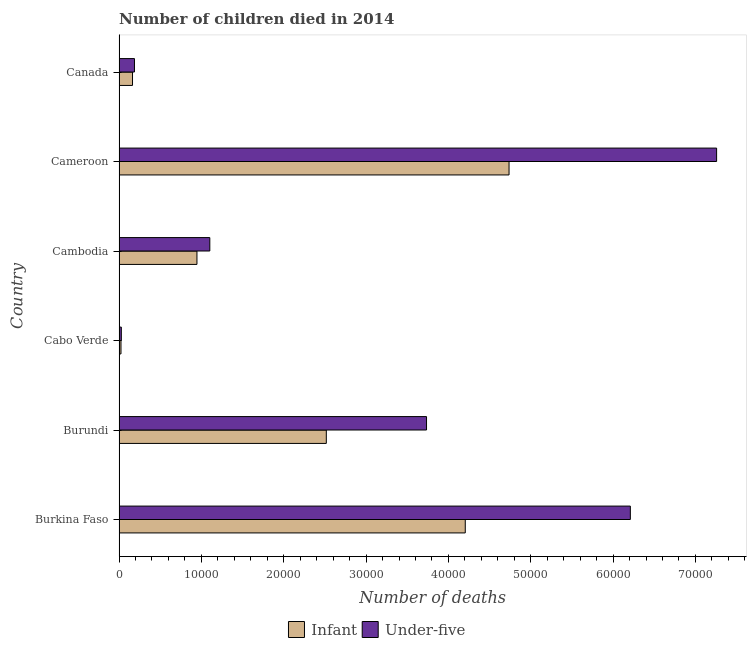How many groups of bars are there?
Make the answer very short. 6. Are the number of bars per tick equal to the number of legend labels?
Your answer should be compact. Yes. How many bars are there on the 6th tick from the top?
Give a very brief answer. 2. What is the label of the 2nd group of bars from the top?
Your answer should be compact. Cameroon. What is the number of infant deaths in Canada?
Provide a short and direct response. 1636. Across all countries, what is the maximum number of under-five deaths?
Provide a short and direct response. 7.26e+04. Across all countries, what is the minimum number of infant deaths?
Provide a short and direct response. 235. In which country was the number of infant deaths maximum?
Your answer should be very brief. Cameroon. In which country was the number of under-five deaths minimum?
Your response must be concise. Cabo Verde. What is the total number of under-five deaths in the graph?
Provide a short and direct response. 1.85e+05. What is the difference between the number of infant deaths in Cabo Verde and that in Cameroon?
Your answer should be very brief. -4.71e+04. What is the difference between the number of under-five deaths in Cameroon and the number of infant deaths in Cambodia?
Ensure brevity in your answer.  6.31e+04. What is the average number of infant deaths per country?
Your answer should be very brief. 2.10e+04. What is the difference between the number of under-five deaths and number of infant deaths in Cabo Verde?
Ensure brevity in your answer.  42. In how many countries, is the number of under-five deaths greater than 48000 ?
Your answer should be compact. 2. What is the ratio of the number of infant deaths in Cabo Verde to that in Cambodia?
Ensure brevity in your answer.  0.03. Is the number of under-five deaths in Burkina Faso less than that in Burundi?
Ensure brevity in your answer.  No. Is the difference between the number of under-five deaths in Burundi and Cambodia greater than the difference between the number of infant deaths in Burundi and Cambodia?
Keep it short and to the point. Yes. What is the difference between the highest and the second highest number of infant deaths?
Your answer should be compact. 5317. What is the difference between the highest and the lowest number of infant deaths?
Ensure brevity in your answer.  4.71e+04. In how many countries, is the number of infant deaths greater than the average number of infant deaths taken over all countries?
Offer a very short reply. 3. What does the 1st bar from the top in Cameroon represents?
Offer a very short reply. Under-five. What does the 2nd bar from the bottom in Burundi represents?
Offer a terse response. Under-five. How many bars are there?
Provide a succinct answer. 12. Are all the bars in the graph horizontal?
Keep it short and to the point. Yes. Are the values on the major ticks of X-axis written in scientific E-notation?
Make the answer very short. No. How many legend labels are there?
Keep it short and to the point. 2. How are the legend labels stacked?
Make the answer very short. Horizontal. What is the title of the graph?
Your response must be concise. Number of children died in 2014. What is the label or title of the X-axis?
Provide a short and direct response. Number of deaths. What is the label or title of the Y-axis?
Your answer should be very brief. Country. What is the Number of deaths of Infant in Burkina Faso?
Ensure brevity in your answer.  4.20e+04. What is the Number of deaths in Under-five in Burkina Faso?
Make the answer very short. 6.21e+04. What is the Number of deaths in Infant in Burundi?
Make the answer very short. 2.52e+04. What is the Number of deaths in Under-five in Burundi?
Your response must be concise. 3.73e+04. What is the Number of deaths of Infant in Cabo Verde?
Give a very brief answer. 235. What is the Number of deaths in Under-five in Cabo Verde?
Your answer should be very brief. 277. What is the Number of deaths of Infant in Cambodia?
Make the answer very short. 9461. What is the Number of deaths in Under-five in Cambodia?
Offer a terse response. 1.10e+04. What is the Number of deaths in Infant in Cameroon?
Give a very brief answer. 4.74e+04. What is the Number of deaths of Under-five in Cameroon?
Your answer should be compact. 7.26e+04. What is the Number of deaths of Infant in Canada?
Keep it short and to the point. 1636. What is the Number of deaths of Under-five in Canada?
Your answer should be very brief. 1872. Across all countries, what is the maximum Number of deaths of Infant?
Give a very brief answer. 4.74e+04. Across all countries, what is the maximum Number of deaths of Under-five?
Offer a terse response. 7.26e+04. Across all countries, what is the minimum Number of deaths in Infant?
Ensure brevity in your answer.  235. Across all countries, what is the minimum Number of deaths of Under-five?
Offer a very short reply. 277. What is the total Number of deaths of Infant in the graph?
Your answer should be compact. 1.26e+05. What is the total Number of deaths in Under-five in the graph?
Offer a very short reply. 1.85e+05. What is the difference between the Number of deaths in Infant in Burkina Faso and that in Burundi?
Provide a succinct answer. 1.69e+04. What is the difference between the Number of deaths in Under-five in Burkina Faso and that in Burundi?
Your response must be concise. 2.48e+04. What is the difference between the Number of deaths of Infant in Burkina Faso and that in Cabo Verde?
Offer a terse response. 4.18e+04. What is the difference between the Number of deaths of Under-five in Burkina Faso and that in Cabo Verde?
Give a very brief answer. 6.18e+04. What is the difference between the Number of deaths of Infant in Burkina Faso and that in Cambodia?
Ensure brevity in your answer.  3.26e+04. What is the difference between the Number of deaths of Under-five in Burkina Faso and that in Cambodia?
Offer a terse response. 5.11e+04. What is the difference between the Number of deaths of Infant in Burkina Faso and that in Cameroon?
Provide a succinct answer. -5317. What is the difference between the Number of deaths in Under-five in Burkina Faso and that in Cameroon?
Keep it short and to the point. -1.05e+04. What is the difference between the Number of deaths of Infant in Burkina Faso and that in Canada?
Provide a succinct answer. 4.04e+04. What is the difference between the Number of deaths of Under-five in Burkina Faso and that in Canada?
Your response must be concise. 6.02e+04. What is the difference between the Number of deaths of Infant in Burundi and that in Cabo Verde?
Offer a terse response. 2.49e+04. What is the difference between the Number of deaths of Under-five in Burundi and that in Cabo Verde?
Provide a short and direct response. 3.71e+04. What is the difference between the Number of deaths of Infant in Burundi and that in Cambodia?
Make the answer very short. 1.57e+04. What is the difference between the Number of deaths in Under-five in Burundi and that in Cambodia?
Provide a succinct answer. 2.63e+04. What is the difference between the Number of deaths in Infant in Burundi and that in Cameroon?
Keep it short and to the point. -2.22e+04. What is the difference between the Number of deaths in Under-five in Burundi and that in Cameroon?
Keep it short and to the point. -3.52e+04. What is the difference between the Number of deaths of Infant in Burundi and that in Canada?
Your response must be concise. 2.35e+04. What is the difference between the Number of deaths in Under-five in Burundi and that in Canada?
Your answer should be very brief. 3.55e+04. What is the difference between the Number of deaths of Infant in Cabo Verde and that in Cambodia?
Offer a very short reply. -9226. What is the difference between the Number of deaths of Under-five in Cabo Verde and that in Cambodia?
Your response must be concise. -1.07e+04. What is the difference between the Number of deaths of Infant in Cabo Verde and that in Cameroon?
Offer a terse response. -4.71e+04. What is the difference between the Number of deaths in Under-five in Cabo Verde and that in Cameroon?
Your answer should be compact. -7.23e+04. What is the difference between the Number of deaths of Infant in Cabo Verde and that in Canada?
Your answer should be very brief. -1401. What is the difference between the Number of deaths of Under-five in Cabo Verde and that in Canada?
Your response must be concise. -1595. What is the difference between the Number of deaths of Infant in Cambodia and that in Cameroon?
Provide a succinct answer. -3.79e+04. What is the difference between the Number of deaths of Under-five in Cambodia and that in Cameroon?
Your answer should be very brief. -6.16e+04. What is the difference between the Number of deaths of Infant in Cambodia and that in Canada?
Your response must be concise. 7825. What is the difference between the Number of deaths of Under-five in Cambodia and that in Canada?
Provide a short and direct response. 9150. What is the difference between the Number of deaths of Infant in Cameroon and that in Canada?
Offer a very short reply. 4.57e+04. What is the difference between the Number of deaths in Under-five in Cameroon and that in Canada?
Give a very brief answer. 7.07e+04. What is the difference between the Number of deaths of Infant in Burkina Faso and the Number of deaths of Under-five in Burundi?
Provide a succinct answer. 4705. What is the difference between the Number of deaths in Infant in Burkina Faso and the Number of deaths in Under-five in Cabo Verde?
Ensure brevity in your answer.  4.18e+04. What is the difference between the Number of deaths of Infant in Burkina Faso and the Number of deaths of Under-five in Cambodia?
Offer a terse response. 3.10e+04. What is the difference between the Number of deaths of Infant in Burkina Faso and the Number of deaths of Under-five in Cameroon?
Give a very brief answer. -3.05e+04. What is the difference between the Number of deaths in Infant in Burkina Faso and the Number of deaths in Under-five in Canada?
Your answer should be compact. 4.02e+04. What is the difference between the Number of deaths in Infant in Burundi and the Number of deaths in Under-five in Cabo Verde?
Offer a terse response. 2.49e+04. What is the difference between the Number of deaths of Infant in Burundi and the Number of deaths of Under-five in Cambodia?
Ensure brevity in your answer.  1.42e+04. What is the difference between the Number of deaths of Infant in Burundi and the Number of deaths of Under-five in Cameroon?
Ensure brevity in your answer.  -4.74e+04. What is the difference between the Number of deaths of Infant in Burundi and the Number of deaths of Under-five in Canada?
Keep it short and to the point. 2.33e+04. What is the difference between the Number of deaths of Infant in Cabo Verde and the Number of deaths of Under-five in Cambodia?
Make the answer very short. -1.08e+04. What is the difference between the Number of deaths of Infant in Cabo Verde and the Number of deaths of Under-five in Cameroon?
Make the answer very short. -7.23e+04. What is the difference between the Number of deaths of Infant in Cabo Verde and the Number of deaths of Under-five in Canada?
Ensure brevity in your answer.  -1637. What is the difference between the Number of deaths of Infant in Cambodia and the Number of deaths of Under-five in Cameroon?
Make the answer very short. -6.31e+04. What is the difference between the Number of deaths of Infant in Cambodia and the Number of deaths of Under-five in Canada?
Provide a short and direct response. 7589. What is the difference between the Number of deaths of Infant in Cameroon and the Number of deaths of Under-five in Canada?
Your answer should be very brief. 4.55e+04. What is the average Number of deaths of Infant per country?
Offer a very short reply. 2.10e+04. What is the average Number of deaths in Under-five per country?
Provide a succinct answer. 3.09e+04. What is the difference between the Number of deaths in Infant and Number of deaths in Under-five in Burkina Faso?
Your answer should be very brief. -2.00e+04. What is the difference between the Number of deaths in Infant and Number of deaths in Under-five in Burundi?
Keep it short and to the point. -1.22e+04. What is the difference between the Number of deaths in Infant and Number of deaths in Under-five in Cabo Verde?
Ensure brevity in your answer.  -42. What is the difference between the Number of deaths in Infant and Number of deaths in Under-five in Cambodia?
Ensure brevity in your answer.  -1561. What is the difference between the Number of deaths of Infant and Number of deaths of Under-five in Cameroon?
Give a very brief answer. -2.52e+04. What is the difference between the Number of deaths in Infant and Number of deaths in Under-five in Canada?
Provide a succinct answer. -236. What is the ratio of the Number of deaths of Infant in Burkina Faso to that in Burundi?
Offer a very short reply. 1.67. What is the ratio of the Number of deaths in Under-five in Burkina Faso to that in Burundi?
Provide a short and direct response. 1.66. What is the ratio of the Number of deaths of Infant in Burkina Faso to that in Cabo Verde?
Your answer should be compact. 178.93. What is the ratio of the Number of deaths in Under-five in Burkina Faso to that in Cabo Verde?
Offer a very short reply. 224.17. What is the ratio of the Number of deaths of Infant in Burkina Faso to that in Cambodia?
Provide a succinct answer. 4.44. What is the ratio of the Number of deaths in Under-five in Burkina Faso to that in Cambodia?
Offer a terse response. 5.63. What is the ratio of the Number of deaths in Infant in Burkina Faso to that in Cameroon?
Your answer should be compact. 0.89. What is the ratio of the Number of deaths of Under-five in Burkina Faso to that in Cameroon?
Provide a succinct answer. 0.86. What is the ratio of the Number of deaths of Infant in Burkina Faso to that in Canada?
Keep it short and to the point. 25.7. What is the ratio of the Number of deaths of Under-five in Burkina Faso to that in Canada?
Keep it short and to the point. 33.17. What is the ratio of the Number of deaths of Infant in Burundi to that in Cabo Verde?
Keep it short and to the point. 107.11. What is the ratio of the Number of deaths of Under-five in Burundi to that in Cabo Verde?
Provide a short and direct response. 134.81. What is the ratio of the Number of deaths of Infant in Burundi to that in Cambodia?
Provide a succinct answer. 2.66. What is the ratio of the Number of deaths in Under-five in Burundi to that in Cambodia?
Provide a short and direct response. 3.39. What is the ratio of the Number of deaths in Infant in Burundi to that in Cameroon?
Your answer should be compact. 0.53. What is the ratio of the Number of deaths of Under-five in Burundi to that in Cameroon?
Give a very brief answer. 0.51. What is the ratio of the Number of deaths in Infant in Burundi to that in Canada?
Keep it short and to the point. 15.39. What is the ratio of the Number of deaths of Under-five in Burundi to that in Canada?
Ensure brevity in your answer.  19.95. What is the ratio of the Number of deaths of Infant in Cabo Verde to that in Cambodia?
Provide a succinct answer. 0.02. What is the ratio of the Number of deaths of Under-five in Cabo Verde to that in Cambodia?
Make the answer very short. 0.03. What is the ratio of the Number of deaths in Infant in Cabo Verde to that in Cameroon?
Keep it short and to the point. 0.01. What is the ratio of the Number of deaths of Under-five in Cabo Verde to that in Cameroon?
Your response must be concise. 0. What is the ratio of the Number of deaths of Infant in Cabo Verde to that in Canada?
Your answer should be compact. 0.14. What is the ratio of the Number of deaths of Under-five in Cabo Verde to that in Canada?
Offer a very short reply. 0.15. What is the ratio of the Number of deaths in Infant in Cambodia to that in Cameroon?
Give a very brief answer. 0.2. What is the ratio of the Number of deaths in Under-five in Cambodia to that in Cameroon?
Provide a short and direct response. 0.15. What is the ratio of the Number of deaths in Infant in Cambodia to that in Canada?
Keep it short and to the point. 5.78. What is the ratio of the Number of deaths in Under-five in Cambodia to that in Canada?
Offer a very short reply. 5.89. What is the ratio of the Number of deaths of Infant in Cameroon to that in Canada?
Make the answer very short. 28.95. What is the ratio of the Number of deaths in Under-five in Cameroon to that in Canada?
Make the answer very short. 38.77. What is the difference between the highest and the second highest Number of deaths in Infant?
Make the answer very short. 5317. What is the difference between the highest and the second highest Number of deaths of Under-five?
Make the answer very short. 1.05e+04. What is the difference between the highest and the lowest Number of deaths in Infant?
Your answer should be compact. 4.71e+04. What is the difference between the highest and the lowest Number of deaths in Under-five?
Offer a very short reply. 7.23e+04. 